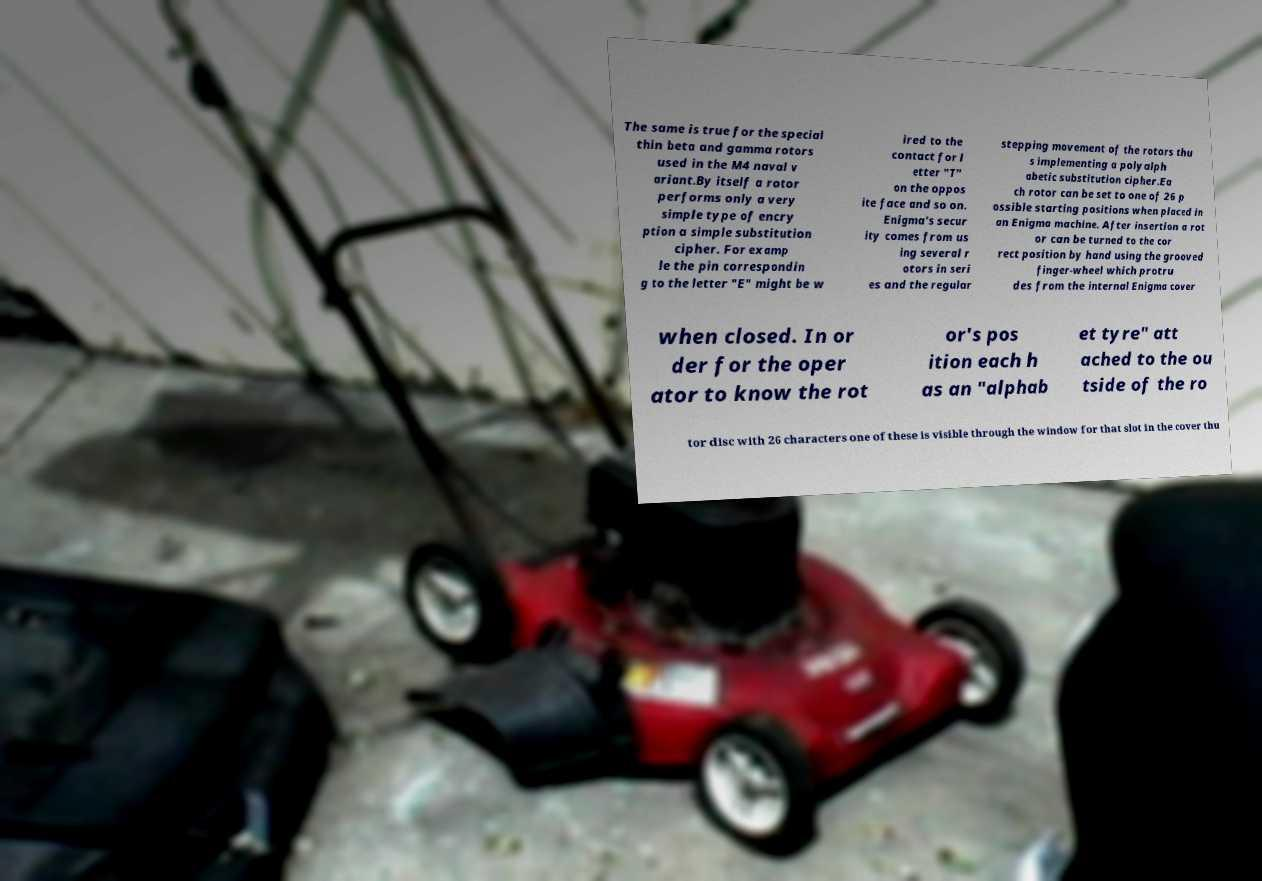For documentation purposes, I need the text within this image transcribed. Could you provide that? The same is true for the special thin beta and gamma rotors used in the M4 naval v ariant.By itself a rotor performs only a very simple type of encry ption a simple substitution cipher. For examp le the pin correspondin g to the letter "E" might be w ired to the contact for l etter "T" on the oppos ite face and so on. Enigma's secur ity comes from us ing several r otors in seri es and the regular stepping movement of the rotors thu s implementing a polyalph abetic substitution cipher.Ea ch rotor can be set to one of 26 p ossible starting positions when placed in an Enigma machine. After insertion a rot or can be turned to the cor rect position by hand using the grooved finger-wheel which protru des from the internal Enigma cover when closed. In or der for the oper ator to know the rot or's pos ition each h as an "alphab et tyre" att ached to the ou tside of the ro tor disc with 26 characters one of these is visible through the window for that slot in the cover thu 